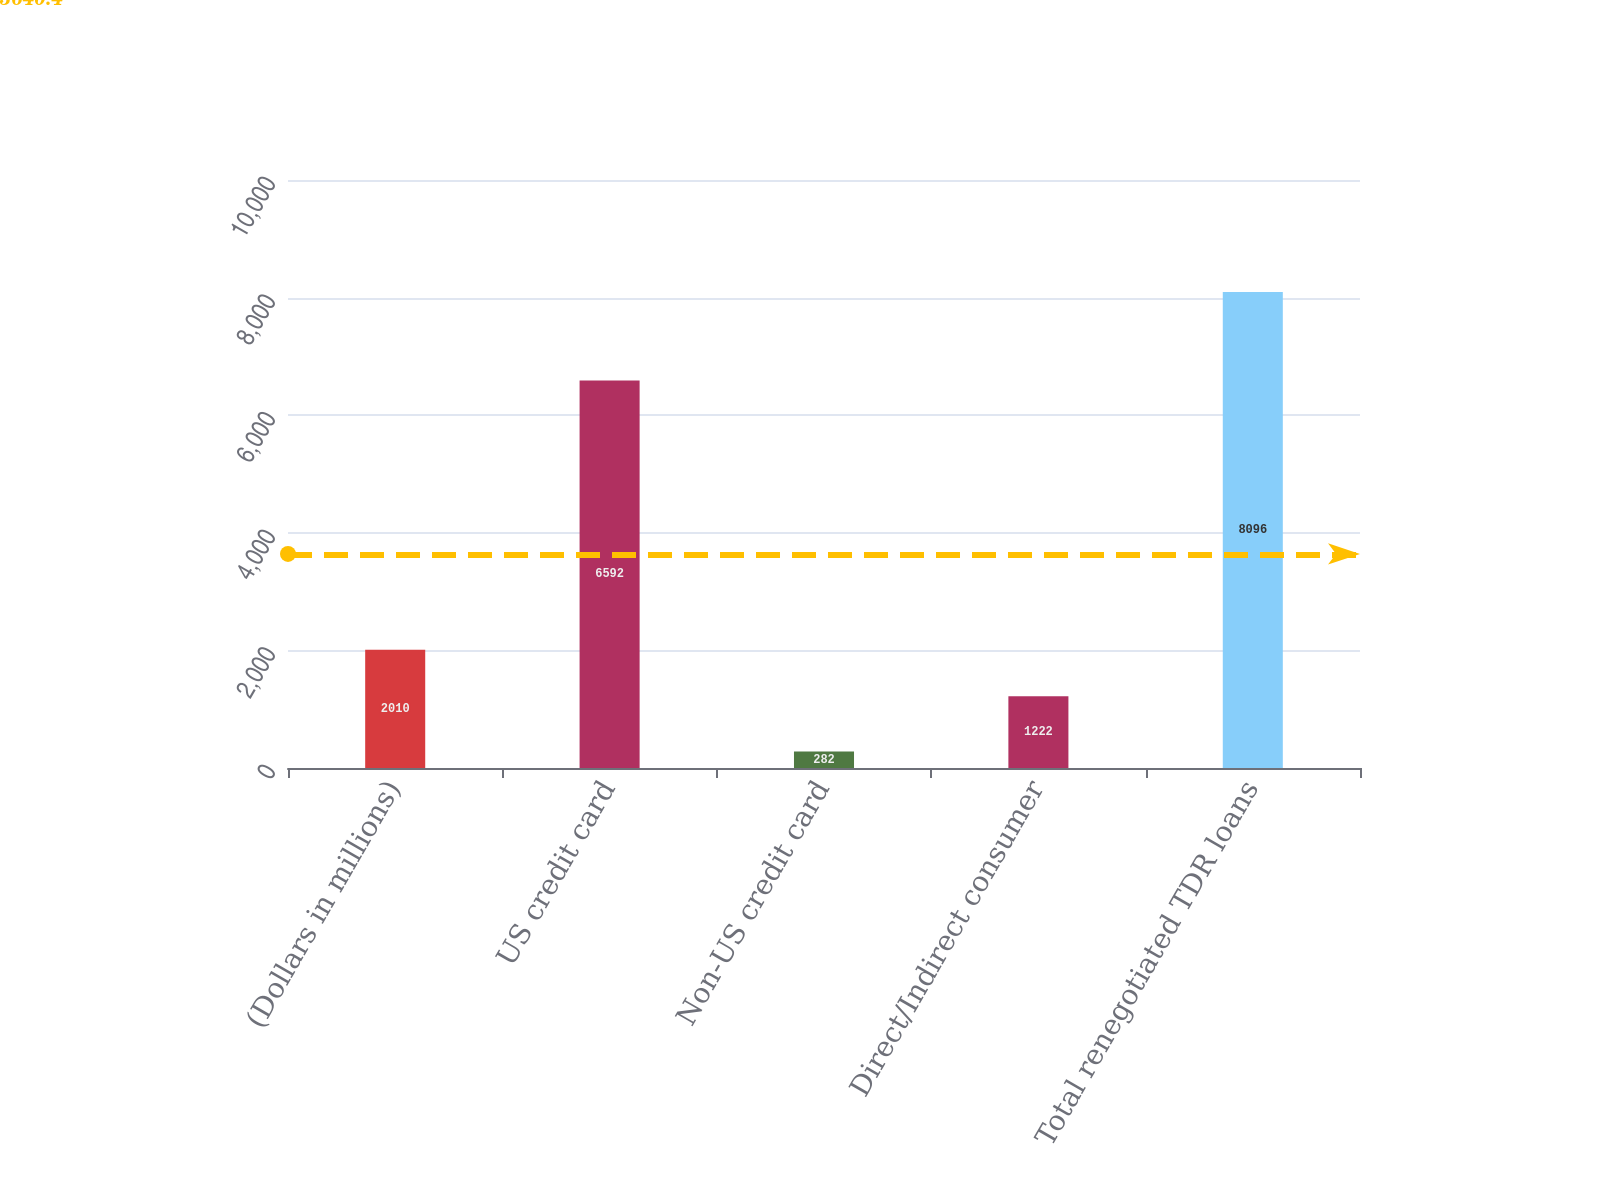Convert chart. <chart><loc_0><loc_0><loc_500><loc_500><bar_chart><fcel>(Dollars in millions)<fcel>US credit card<fcel>Non-US credit card<fcel>Direct/Indirect consumer<fcel>Total renegotiated TDR loans<nl><fcel>2010<fcel>6592<fcel>282<fcel>1222<fcel>8096<nl></chart> 